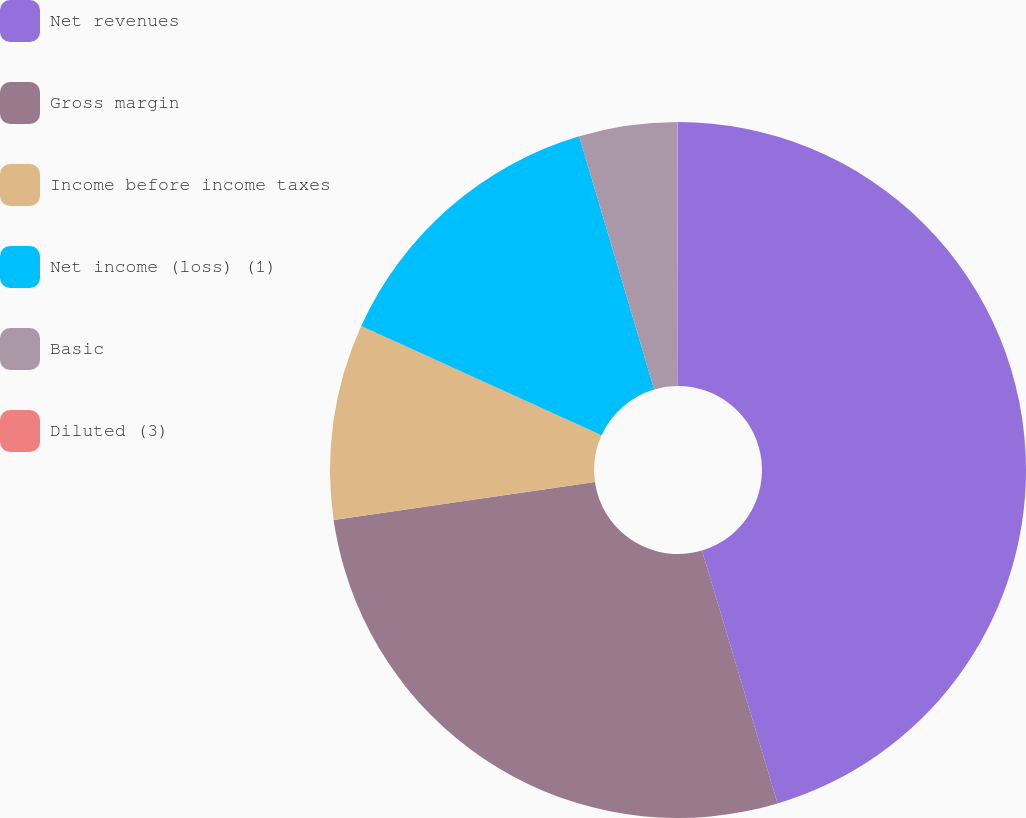<chart> <loc_0><loc_0><loc_500><loc_500><pie_chart><fcel>Net revenues<fcel>Gross margin<fcel>Income before income taxes<fcel>Net income (loss) (1)<fcel>Basic<fcel>Diluted (3)<nl><fcel>45.38%<fcel>27.32%<fcel>9.09%<fcel>13.63%<fcel>4.56%<fcel>0.02%<nl></chart> 